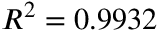Convert formula to latex. <formula><loc_0><loc_0><loc_500><loc_500>R ^ { 2 } = 0 . 9 9 3 2</formula> 